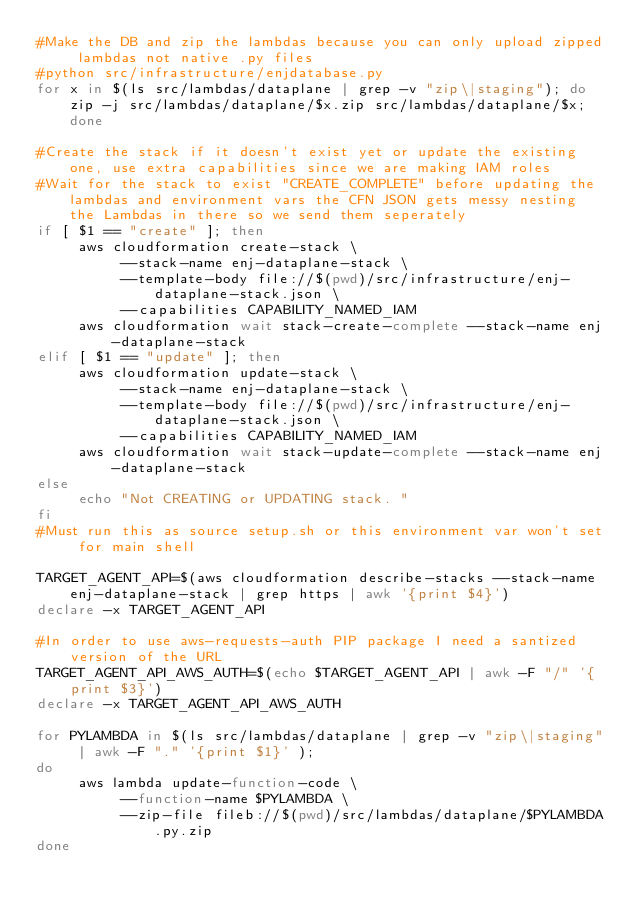<code> <loc_0><loc_0><loc_500><loc_500><_Bash_>#Make the DB and zip the lambdas because you can only upload zipped lambdas not native .py files
#python src/infrastructure/enjdatabase.py
for x in $(ls src/lambdas/dataplane | grep -v "zip\|staging"); do zip -j src/lambdas/dataplane/$x.zip src/lambdas/dataplane/$x; done

#Create the stack if it doesn't exist yet or update the existing one, use extra capabilities since we are making IAM roles
#Wait for the stack to exist "CREATE_COMPLETE" before updating the lambdas and environment vars the CFN JSON gets messy nesting the Lambdas in there so we send them seperately
if [ $1 == "create" ]; then
     aws cloudformation create-stack \
          --stack-name enj-dataplane-stack \
          --template-body file://$(pwd)/src/infrastructure/enj-dataplane-stack.json \
          --capabilities CAPABILITY_NAMED_IAM
     aws cloudformation wait stack-create-complete --stack-name enj-dataplane-stack
elif [ $1 == "update" ]; then
     aws cloudformation update-stack \
          --stack-name enj-dataplane-stack \
          --template-body file://$(pwd)/src/infrastructure/enj-dataplane-stack.json \
          --capabilities CAPABILITY_NAMED_IAM
     aws cloudformation wait stack-update-complete --stack-name enj-dataplane-stack
else
     echo "Not CREATING or UPDATING stack. "
fi
#Must run this as source setup.sh or this environment var won't set for main shell

TARGET_AGENT_API=$(aws cloudformation describe-stacks --stack-name enj-dataplane-stack | grep https | awk '{print $4}')
declare -x TARGET_AGENT_API 

#In order to use aws-requests-auth PIP package I need a santized version of the URL
TARGET_AGENT_API_AWS_AUTH=$(echo $TARGET_AGENT_API | awk -F "/" '{print $3}')
declare -x TARGET_AGENT_API_AWS_AUTH

for PYLAMBDA in $(ls src/lambdas/dataplane | grep -v "zip\|staging" | awk -F "." '{print $1}' ); 
do 
     aws lambda update-function-code \
          --function-name $PYLAMBDA \
          --zip-file fileb://$(pwd)/src/lambdas/dataplane/$PYLAMBDA.py.zip
done
</code> 